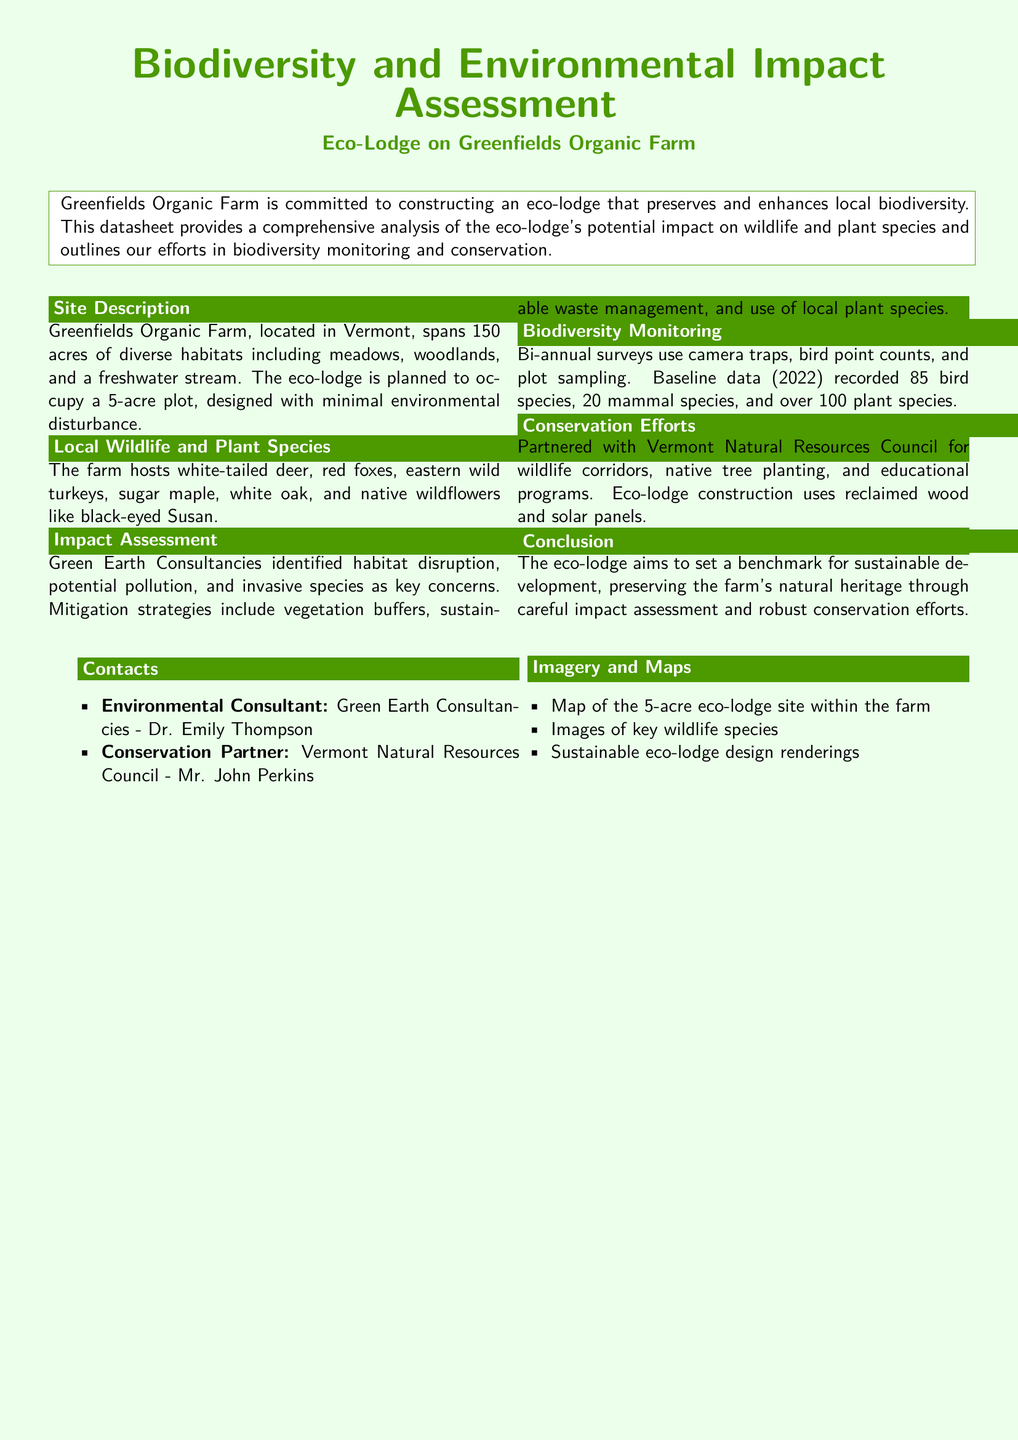What is the total area of Greenfields Organic Farm? The total area is mentioned in the document, which states that the farm spans 150 acres.
Answer: 150 acres How many bi-annual surveys are conducted? The document mentions that bi-annual surveys are conducted. Bi-annual implies twice a year.
Answer: Two Which environmental consultancy was involved? The document names Green Earth Consultancies as the environmental consultant.
Answer: Green Earth Consultancies What types of habitats are present on the farm? The document mentions diverse habitats including meadows, woodlands, and a freshwater stream.
Answer: Meadows, woodlands, and freshwater stream What is a key conservation effort mentioned in the document? The document highlights the partnership with the Vermont Natural Resources Council for wildlife corridors as a conservation effort.
Answer: Wildlife corridors How many bird species were recorded in the baseline data? The document states that 85 bird species were recorded in the baseline data.
Answer: 85 What materials are used for eco-lodge construction? The document specifies that reclaimed wood and solar panels are used in construction.
Answer: Reclaimed wood and solar panels What is the primary concern related to the eco-lodge's environmental impact? The document lists habitat disruption, potential pollution, and invasive species as key concerns, making it a shared concern.
Answer: Habitat disruption What is the size of the plot designated for the eco-lodge? The document indicates that the eco-lodge is planned to occupy a 5-acre plot.
Answer: 5 acres 